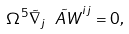Convert formula to latex. <formula><loc_0><loc_0><loc_500><loc_500>\Omega ^ { 5 } \tilde { \nabla } _ { j } \tilde { \ A W } ^ { i j } = 0 ,</formula> 